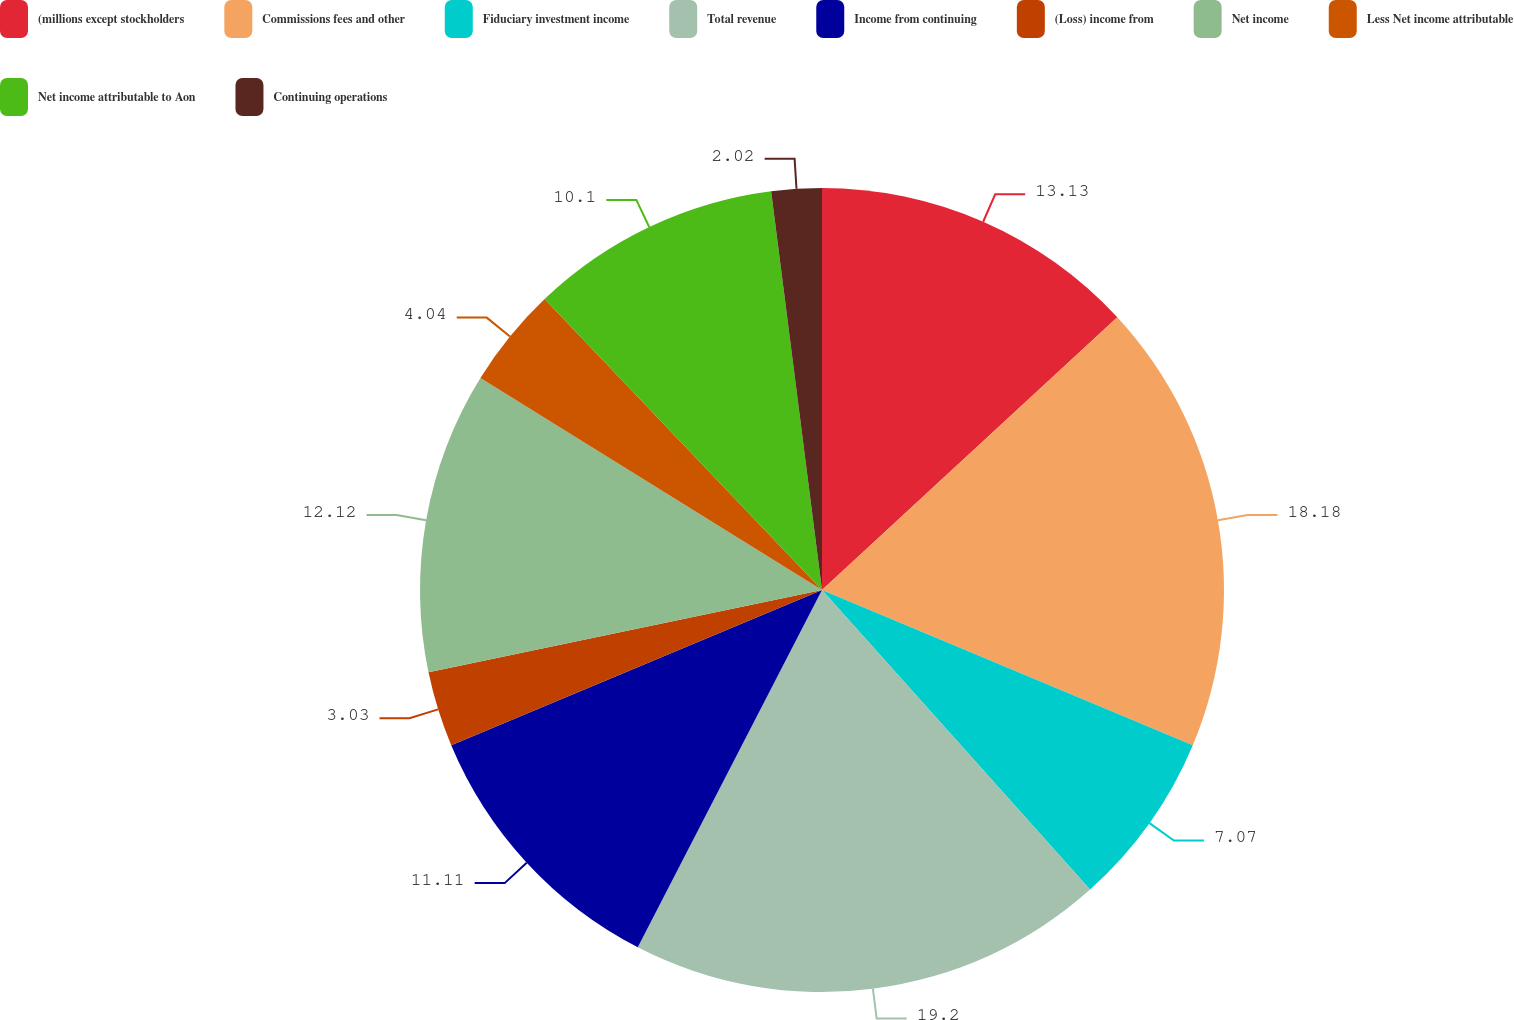Convert chart to OTSL. <chart><loc_0><loc_0><loc_500><loc_500><pie_chart><fcel>(millions except stockholders<fcel>Commissions fees and other<fcel>Fiduciary investment income<fcel>Total revenue<fcel>Income from continuing<fcel>(Loss) income from<fcel>Net income<fcel>Less Net income attributable<fcel>Net income attributable to Aon<fcel>Continuing operations<nl><fcel>13.13%<fcel>18.18%<fcel>7.07%<fcel>19.19%<fcel>11.11%<fcel>3.03%<fcel>12.12%<fcel>4.04%<fcel>10.1%<fcel>2.02%<nl></chart> 